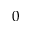Convert formula to latex. <formula><loc_0><loc_0><loc_500><loc_500>0</formula> 